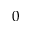Convert formula to latex. <formula><loc_0><loc_0><loc_500><loc_500>0</formula> 